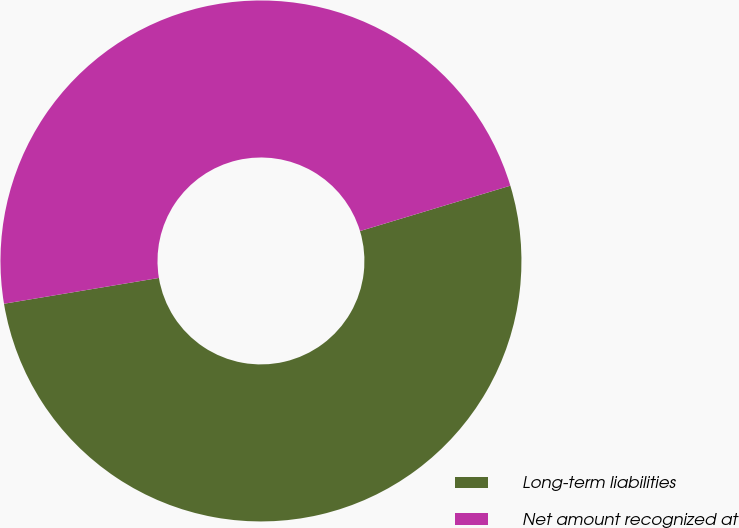Convert chart to OTSL. <chart><loc_0><loc_0><loc_500><loc_500><pie_chart><fcel>Long-term liabilities<fcel>Net amount recognized at<nl><fcel>52.04%<fcel>47.96%<nl></chart> 